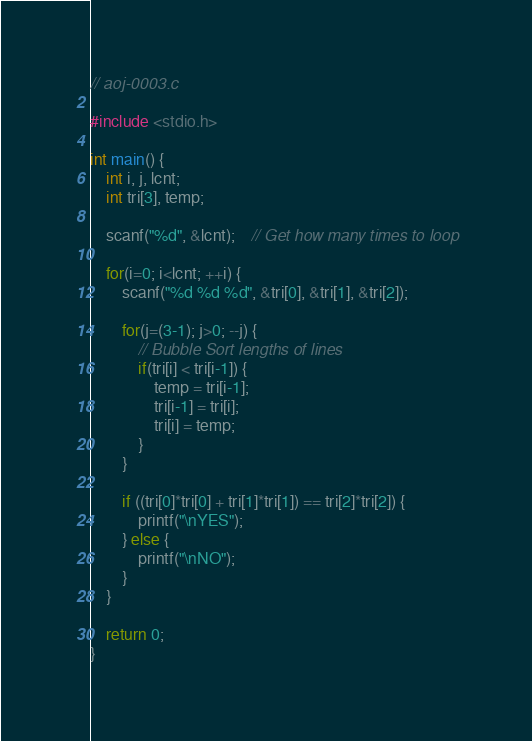<code> <loc_0><loc_0><loc_500><loc_500><_C_>// aoj-0003.c

#include <stdio.h>

int main() {
	int i, j, lcnt;
	int tri[3], temp;
	
	scanf("%d", &lcnt);	// Get how many times to loop
	
	for(i=0; i<lcnt; ++i) {
		scanf("%d %d %d", &tri[0], &tri[1], &tri[2]);
		
		for(j=(3-1); j>0; --j) {
			// Bubble Sort lengths of lines
			if(tri[i] < tri[i-1]) {
				temp = tri[i-1];
				tri[i-1] = tri[i];
				tri[i] = temp;
			}
		}
		
		if ((tri[0]*tri[0] + tri[1]*tri[1]) == tri[2]*tri[2]) {
			printf("\nYES");
		} else {
			printf("\nNO");
		}
	}
	
	return 0;
}</code> 